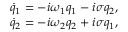<formula> <loc_0><loc_0><loc_500><loc_500>\begin{array} { r } { \dot { q } _ { 1 } = - i \omega _ { 1 } q _ { 1 } - i \sigma q _ { 2 } , } \\ { \dot { q } _ { 2 } = - i \omega _ { 2 } q _ { 2 } + i \sigma q _ { 1 } , } \end{array}</formula> 